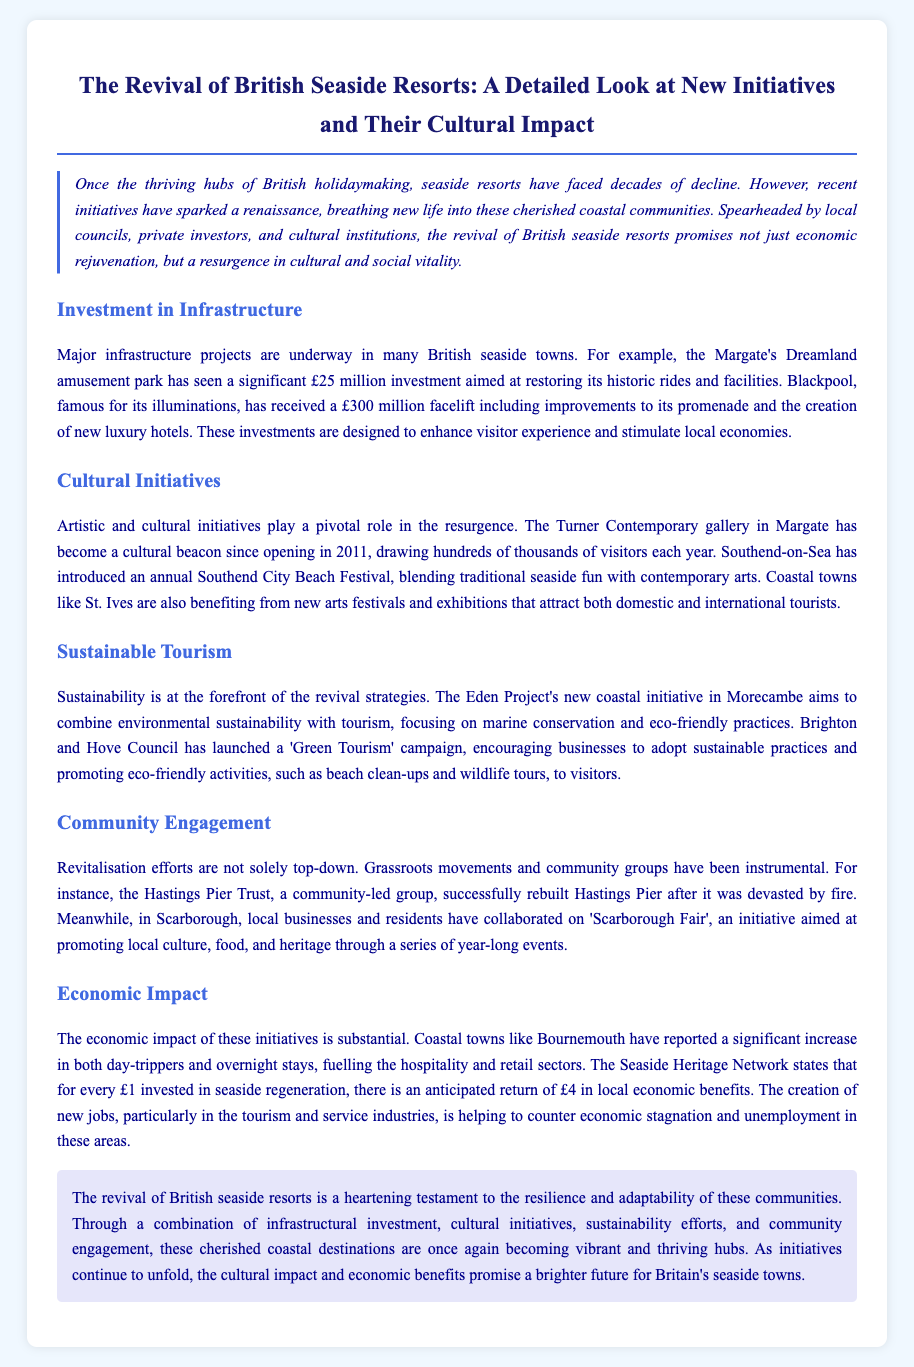what investment did Margate's Dreamland amusement park receive? The document states that Margate's Dreamland received a £25 million investment for restoring its historic rides and facilities.
Answer: £25 million what is the estimated return on investment for every £1 in seaside regeneration? According to the Seaside Heritage Network, the anticipated return is £4 in local economic benefits for every £1 invested.
Answer: £4 which seaside town introduced an annual beach festival? The document mentions that Southend-on-Sea introduced the Southend City Beach Festival.
Answer: Southend-on-Sea who rebuilt Hastings Pier after it was devastated by fire? The community-led group Hastings Pier Trust successfully rebuilt Hastings Pier.
Answer: Hastings Pier Trust what campaign has Brighton and Hove Council launched? The council has launched a 'Green Tourism' campaign promoting sustainable practices among businesses.
Answer: Green Tourism what was the total investment for Blackpool's improvements? The document indicates that Blackpool received a £300 million facelift for its improvements.
Answer: £300 million how do local businesses contribute to Scarborough's cultural initiatives? Local businesses collaborated on 'Scarborough Fair', promoting culture, food, and heritage through events.
Answer: Scarborough Fair what is a major cultural institution in Margate mentioned in the document? The Turner Contemporary gallery is identified as a major cultural institution in Margate.
Answer: Turner Contemporary what is the focus of the Eden Project’s new coastal initiative in Morecambe? The focus is on combining environmental sustainability with tourism, particularly marine conservation.
Answer: Marine conservation 